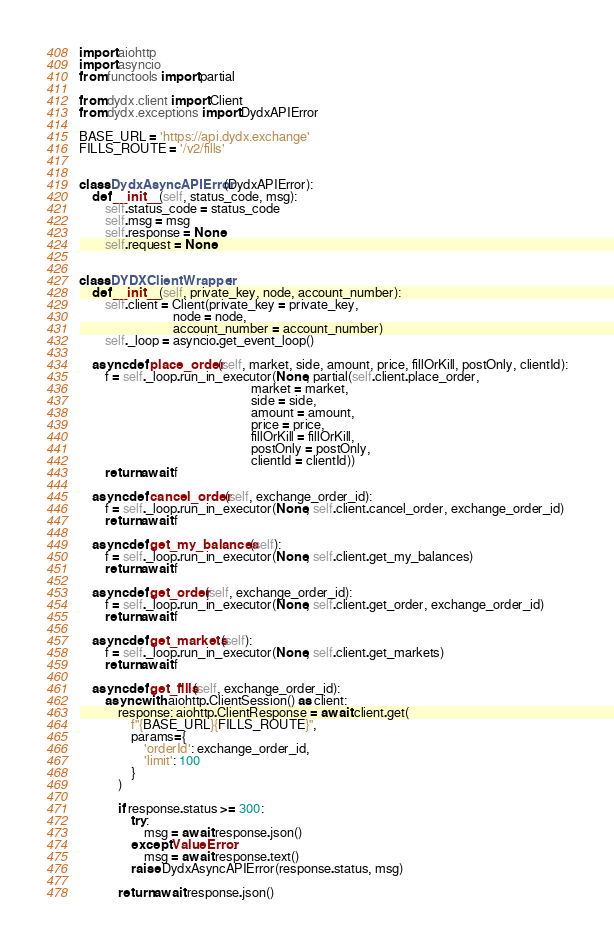<code> <loc_0><loc_0><loc_500><loc_500><_Python_>import aiohttp
import asyncio
from functools import partial

from dydx.client import Client
from dydx.exceptions import DydxAPIError

BASE_URL = 'https://api.dydx.exchange'
FILLS_ROUTE = '/v2/fills'


class DydxAsyncAPIError(DydxAPIError):
    def __init__(self, status_code, msg):
        self.status_code = status_code
        self.msg = msg
        self.response = None
        self.request = None


class DYDXClientWrapper:
    def __init__(self, private_key, node, account_number):
        self.client = Client(private_key = private_key,
                             node = node,
                             account_number = account_number)
        self._loop = asyncio.get_event_loop()

    async def place_order(self, market, side, amount, price, fillOrKill, postOnly, clientId):
        f = self._loop.run_in_executor(None, partial(self.client.place_order,
                                                     market = market,
                                                     side = side,
                                                     amount = amount,
                                                     price = price,
                                                     fillOrKill = fillOrKill,
                                                     postOnly = postOnly,
                                                     clientId = clientId))
        return await f

    async def cancel_order(self, exchange_order_id):
        f = self._loop.run_in_executor(None, self.client.cancel_order, exchange_order_id)
        return await f

    async def get_my_balances(self):
        f = self._loop.run_in_executor(None, self.client.get_my_balances)
        return await f

    async def get_order(self, exchange_order_id):
        f = self._loop.run_in_executor(None, self.client.get_order, exchange_order_id)
        return await f

    async def get_markets(self):
        f = self._loop.run_in_executor(None, self.client.get_markets)
        return await f

    async def get_fills(self, exchange_order_id):
        async with aiohttp.ClientSession() as client:
            response: aiohttp.ClientResponse = await client.get(
                f"{BASE_URL}{FILLS_ROUTE}",
                params={
                    'orderId': exchange_order_id,
                    'limit': 100
                }
            )

            if response.status >= 300:
                try:
                    msg = await response.json()
                except ValueError:
                    msg = await response.text()
                raise DydxAsyncAPIError(response.status, msg)

            return await response.json()
</code> 